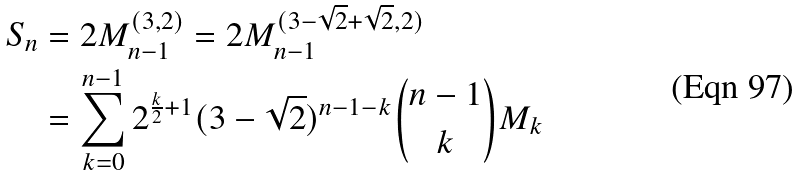Convert formula to latex. <formula><loc_0><loc_0><loc_500><loc_500>S _ { n } & = 2 M _ { n - 1 } ^ { ( 3 , 2 ) } = 2 M _ { n - 1 } ^ { ( 3 - \sqrt { 2 } + \sqrt { 2 } , 2 ) } \\ & = \sum _ { k = 0 } ^ { n - 1 } 2 ^ { \frac { k } { 2 } + 1 } ( 3 - \sqrt { 2 } ) ^ { n - 1 - k } \binom { n - 1 } { k } M _ { k }</formula> 